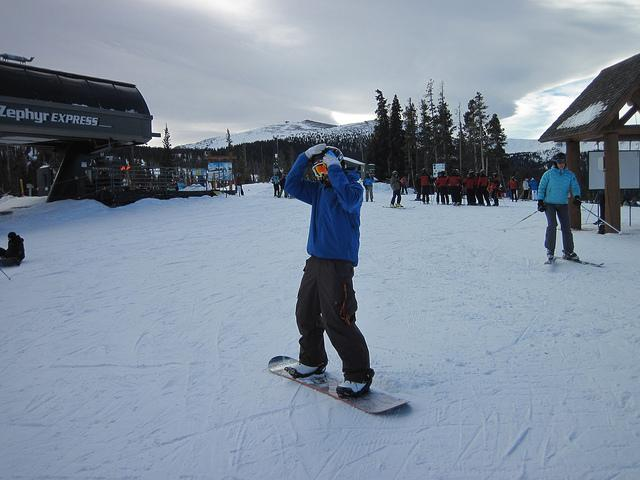What do these men plan to do here? snowboard 